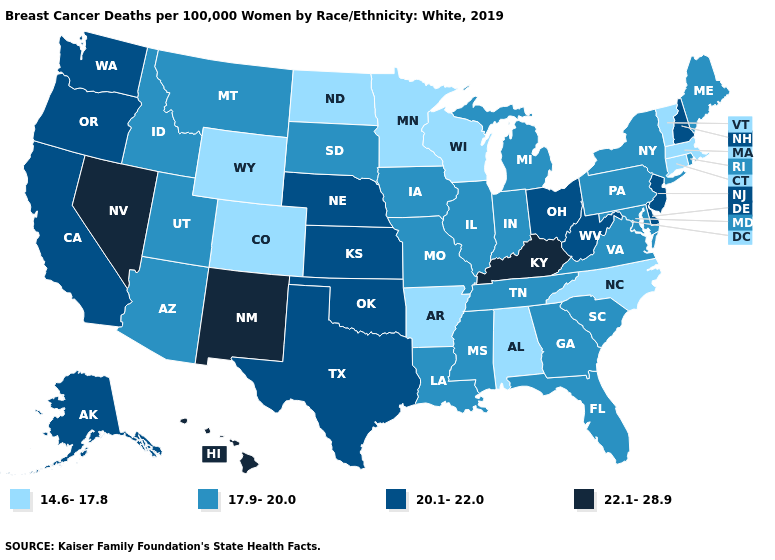Does the map have missing data?
Give a very brief answer. No. Among the states that border Arizona , does New Mexico have the highest value?
Be succinct. Yes. What is the value of New Mexico?
Be succinct. 22.1-28.9. Among the states that border Michigan , which have the highest value?
Be succinct. Ohio. What is the lowest value in states that border Montana?
Answer briefly. 14.6-17.8. Name the states that have a value in the range 14.6-17.8?
Be succinct. Alabama, Arkansas, Colorado, Connecticut, Massachusetts, Minnesota, North Carolina, North Dakota, Vermont, Wisconsin, Wyoming. What is the value of Michigan?
Give a very brief answer. 17.9-20.0. What is the highest value in states that border Nevada?
Keep it brief. 20.1-22.0. Is the legend a continuous bar?
Short answer required. No. Does Rhode Island have the highest value in the USA?
Concise answer only. No. Does North Carolina have the lowest value in the USA?
Be succinct. Yes. Name the states that have a value in the range 20.1-22.0?
Concise answer only. Alaska, California, Delaware, Kansas, Nebraska, New Hampshire, New Jersey, Ohio, Oklahoma, Oregon, Texas, Washington, West Virginia. Is the legend a continuous bar?
Write a very short answer. No. Among the states that border Oregon , which have the highest value?
Give a very brief answer. Nevada. 